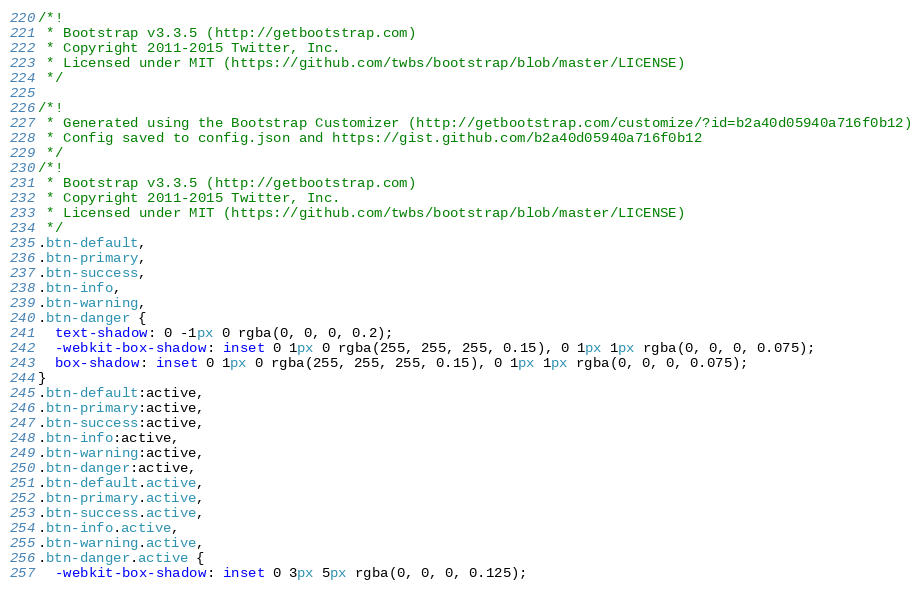Convert code to text. <code><loc_0><loc_0><loc_500><loc_500><_CSS_>/*!
 * Bootstrap v3.3.5 (http://getbootstrap.com)
 * Copyright 2011-2015 Twitter, Inc.
 * Licensed under MIT (https://github.com/twbs/bootstrap/blob/master/LICENSE)
 */

/*!
 * Generated using the Bootstrap Customizer (http://getbootstrap.com/customize/?id=b2a40d05940a716f0b12)
 * Config saved to config.json and https://gist.github.com/b2a40d05940a716f0b12
 */
/*!
 * Bootstrap v3.3.5 (http://getbootstrap.com)
 * Copyright 2011-2015 Twitter, Inc.
 * Licensed under MIT (https://github.com/twbs/bootstrap/blob/master/LICENSE)
 */
.btn-default,
.btn-primary,
.btn-success,
.btn-info,
.btn-warning,
.btn-danger {
  text-shadow: 0 -1px 0 rgba(0, 0, 0, 0.2);
  -webkit-box-shadow: inset 0 1px 0 rgba(255, 255, 255, 0.15), 0 1px 1px rgba(0, 0, 0, 0.075);
  box-shadow: inset 0 1px 0 rgba(255, 255, 255, 0.15), 0 1px 1px rgba(0, 0, 0, 0.075);
}
.btn-default:active,
.btn-primary:active,
.btn-success:active,
.btn-info:active,
.btn-warning:active,
.btn-danger:active,
.btn-default.active,
.btn-primary.active,
.btn-success.active,
.btn-info.active,
.btn-warning.active,
.btn-danger.active {
  -webkit-box-shadow: inset 0 3px 5px rgba(0, 0, 0, 0.125);</code> 